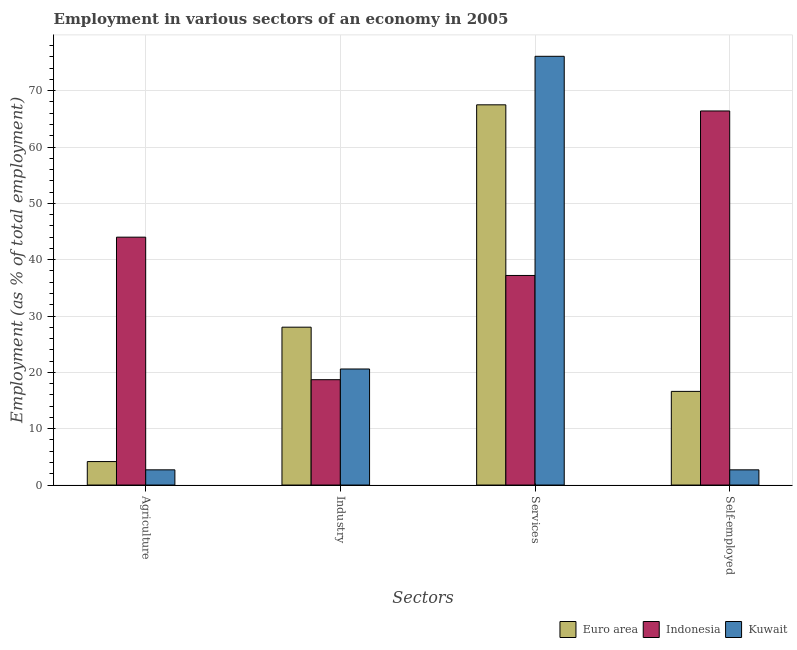How many different coloured bars are there?
Ensure brevity in your answer.  3. How many bars are there on the 2nd tick from the left?
Your answer should be very brief. 3. How many bars are there on the 3rd tick from the right?
Give a very brief answer. 3. What is the label of the 1st group of bars from the left?
Keep it short and to the point. Agriculture. What is the percentage of workers in services in Kuwait?
Provide a succinct answer. 76.1. Across all countries, what is the maximum percentage of workers in services?
Your response must be concise. 76.1. Across all countries, what is the minimum percentage of workers in services?
Give a very brief answer. 37.2. In which country was the percentage of workers in services maximum?
Offer a terse response. Kuwait. In which country was the percentage of workers in services minimum?
Give a very brief answer. Indonesia. What is the total percentage of workers in services in the graph?
Offer a very short reply. 180.79. What is the difference between the percentage of self employed workers in Kuwait and that in Indonesia?
Make the answer very short. -63.7. What is the difference between the percentage of self employed workers in Euro area and the percentage of workers in industry in Kuwait?
Provide a succinct answer. -3.98. What is the average percentage of workers in industry per country?
Your answer should be very brief. 22.44. What is the difference between the percentage of workers in agriculture and percentage of workers in services in Euro area?
Provide a short and direct response. -63.32. What is the ratio of the percentage of workers in services in Kuwait to that in Euro area?
Provide a short and direct response. 1.13. Is the difference between the percentage of workers in industry in Indonesia and Kuwait greater than the difference between the percentage of workers in services in Indonesia and Kuwait?
Give a very brief answer. Yes. What is the difference between the highest and the second highest percentage of workers in agriculture?
Make the answer very short. 39.83. What is the difference between the highest and the lowest percentage of workers in industry?
Provide a short and direct response. 9.32. In how many countries, is the percentage of workers in agriculture greater than the average percentage of workers in agriculture taken over all countries?
Your answer should be compact. 1. Is the sum of the percentage of workers in agriculture in Kuwait and Indonesia greater than the maximum percentage of workers in industry across all countries?
Provide a short and direct response. Yes. Is it the case that in every country, the sum of the percentage of workers in industry and percentage of workers in agriculture is greater than the sum of percentage of workers in services and percentage of self employed workers?
Your answer should be very brief. No. What does the 1st bar from the left in Industry represents?
Ensure brevity in your answer.  Euro area. What does the 1st bar from the right in Services represents?
Your answer should be compact. Kuwait. Is it the case that in every country, the sum of the percentage of workers in agriculture and percentage of workers in industry is greater than the percentage of workers in services?
Offer a terse response. No. How many bars are there?
Keep it short and to the point. 12. Are the values on the major ticks of Y-axis written in scientific E-notation?
Make the answer very short. No. Does the graph contain any zero values?
Offer a very short reply. No. How are the legend labels stacked?
Your answer should be very brief. Horizontal. What is the title of the graph?
Give a very brief answer. Employment in various sectors of an economy in 2005. What is the label or title of the X-axis?
Your response must be concise. Sectors. What is the label or title of the Y-axis?
Your response must be concise. Employment (as % of total employment). What is the Employment (as % of total employment) in Euro area in Agriculture?
Provide a succinct answer. 4.17. What is the Employment (as % of total employment) in Indonesia in Agriculture?
Your answer should be very brief. 44. What is the Employment (as % of total employment) in Kuwait in Agriculture?
Your response must be concise. 2.7. What is the Employment (as % of total employment) in Euro area in Industry?
Provide a short and direct response. 28.02. What is the Employment (as % of total employment) of Indonesia in Industry?
Keep it short and to the point. 18.7. What is the Employment (as % of total employment) of Kuwait in Industry?
Ensure brevity in your answer.  20.6. What is the Employment (as % of total employment) of Euro area in Services?
Ensure brevity in your answer.  67.49. What is the Employment (as % of total employment) of Indonesia in Services?
Provide a short and direct response. 37.2. What is the Employment (as % of total employment) of Kuwait in Services?
Keep it short and to the point. 76.1. What is the Employment (as % of total employment) of Euro area in Self-employed?
Ensure brevity in your answer.  16.62. What is the Employment (as % of total employment) in Indonesia in Self-employed?
Keep it short and to the point. 66.4. What is the Employment (as % of total employment) of Kuwait in Self-employed?
Offer a very short reply. 2.7. Across all Sectors, what is the maximum Employment (as % of total employment) of Euro area?
Provide a succinct answer. 67.49. Across all Sectors, what is the maximum Employment (as % of total employment) in Indonesia?
Offer a terse response. 66.4. Across all Sectors, what is the maximum Employment (as % of total employment) in Kuwait?
Ensure brevity in your answer.  76.1. Across all Sectors, what is the minimum Employment (as % of total employment) of Euro area?
Provide a succinct answer. 4.17. Across all Sectors, what is the minimum Employment (as % of total employment) of Indonesia?
Offer a terse response. 18.7. Across all Sectors, what is the minimum Employment (as % of total employment) of Kuwait?
Your answer should be compact. 2.7. What is the total Employment (as % of total employment) of Euro area in the graph?
Keep it short and to the point. 116.3. What is the total Employment (as % of total employment) in Indonesia in the graph?
Give a very brief answer. 166.3. What is the total Employment (as % of total employment) of Kuwait in the graph?
Provide a succinct answer. 102.1. What is the difference between the Employment (as % of total employment) of Euro area in Agriculture and that in Industry?
Provide a succinct answer. -23.86. What is the difference between the Employment (as % of total employment) in Indonesia in Agriculture and that in Industry?
Offer a very short reply. 25.3. What is the difference between the Employment (as % of total employment) in Kuwait in Agriculture and that in Industry?
Ensure brevity in your answer.  -17.9. What is the difference between the Employment (as % of total employment) in Euro area in Agriculture and that in Services?
Your answer should be compact. -63.32. What is the difference between the Employment (as % of total employment) in Indonesia in Agriculture and that in Services?
Ensure brevity in your answer.  6.8. What is the difference between the Employment (as % of total employment) in Kuwait in Agriculture and that in Services?
Your answer should be very brief. -73.4. What is the difference between the Employment (as % of total employment) in Euro area in Agriculture and that in Self-employed?
Give a very brief answer. -12.46. What is the difference between the Employment (as % of total employment) in Indonesia in Agriculture and that in Self-employed?
Ensure brevity in your answer.  -22.4. What is the difference between the Employment (as % of total employment) in Euro area in Industry and that in Services?
Your response must be concise. -39.47. What is the difference between the Employment (as % of total employment) in Indonesia in Industry and that in Services?
Provide a succinct answer. -18.5. What is the difference between the Employment (as % of total employment) of Kuwait in Industry and that in Services?
Your answer should be compact. -55.5. What is the difference between the Employment (as % of total employment) of Euro area in Industry and that in Self-employed?
Give a very brief answer. 11.4. What is the difference between the Employment (as % of total employment) of Indonesia in Industry and that in Self-employed?
Provide a short and direct response. -47.7. What is the difference between the Employment (as % of total employment) of Kuwait in Industry and that in Self-employed?
Offer a terse response. 17.9. What is the difference between the Employment (as % of total employment) in Euro area in Services and that in Self-employed?
Keep it short and to the point. 50.86. What is the difference between the Employment (as % of total employment) of Indonesia in Services and that in Self-employed?
Give a very brief answer. -29.2. What is the difference between the Employment (as % of total employment) in Kuwait in Services and that in Self-employed?
Offer a terse response. 73.4. What is the difference between the Employment (as % of total employment) in Euro area in Agriculture and the Employment (as % of total employment) in Indonesia in Industry?
Your answer should be compact. -14.53. What is the difference between the Employment (as % of total employment) of Euro area in Agriculture and the Employment (as % of total employment) of Kuwait in Industry?
Provide a succinct answer. -16.43. What is the difference between the Employment (as % of total employment) of Indonesia in Agriculture and the Employment (as % of total employment) of Kuwait in Industry?
Your response must be concise. 23.4. What is the difference between the Employment (as % of total employment) of Euro area in Agriculture and the Employment (as % of total employment) of Indonesia in Services?
Make the answer very short. -33.03. What is the difference between the Employment (as % of total employment) of Euro area in Agriculture and the Employment (as % of total employment) of Kuwait in Services?
Ensure brevity in your answer.  -71.93. What is the difference between the Employment (as % of total employment) in Indonesia in Agriculture and the Employment (as % of total employment) in Kuwait in Services?
Ensure brevity in your answer.  -32.1. What is the difference between the Employment (as % of total employment) of Euro area in Agriculture and the Employment (as % of total employment) of Indonesia in Self-employed?
Keep it short and to the point. -62.23. What is the difference between the Employment (as % of total employment) in Euro area in Agriculture and the Employment (as % of total employment) in Kuwait in Self-employed?
Provide a short and direct response. 1.47. What is the difference between the Employment (as % of total employment) in Indonesia in Agriculture and the Employment (as % of total employment) in Kuwait in Self-employed?
Offer a very short reply. 41.3. What is the difference between the Employment (as % of total employment) of Euro area in Industry and the Employment (as % of total employment) of Indonesia in Services?
Offer a very short reply. -9.18. What is the difference between the Employment (as % of total employment) of Euro area in Industry and the Employment (as % of total employment) of Kuwait in Services?
Keep it short and to the point. -48.08. What is the difference between the Employment (as % of total employment) in Indonesia in Industry and the Employment (as % of total employment) in Kuwait in Services?
Make the answer very short. -57.4. What is the difference between the Employment (as % of total employment) of Euro area in Industry and the Employment (as % of total employment) of Indonesia in Self-employed?
Provide a short and direct response. -38.38. What is the difference between the Employment (as % of total employment) in Euro area in Industry and the Employment (as % of total employment) in Kuwait in Self-employed?
Keep it short and to the point. 25.32. What is the difference between the Employment (as % of total employment) in Indonesia in Industry and the Employment (as % of total employment) in Kuwait in Self-employed?
Provide a succinct answer. 16. What is the difference between the Employment (as % of total employment) in Euro area in Services and the Employment (as % of total employment) in Indonesia in Self-employed?
Your answer should be very brief. 1.09. What is the difference between the Employment (as % of total employment) of Euro area in Services and the Employment (as % of total employment) of Kuwait in Self-employed?
Provide a succinct answer. 64.79. What is the difference between the Employment (as % of total employment) of Indonesia in Services and the Employment (as % of total employment) of Kuwait in Self-employed?
Offer a terse response. 34.5. What is the average Employment (as % of total employment) of Euro area per Sectors?
Your answer should be very brief. 29.07. What is the average Employment (as % of total employment) of Indonesia per Sectors?
Offer a terse response. 41.58. What is the average Employment (as % of total employment) in Kuwait per Sectors?
Offer a terse response. 25.52. What is the difference between the Employment (as % of total employment) in Euro area and Employment (as % of total employment) in Indonesia in Agriculture?
Ensure brevity in your answer.  -39.83. What is the difference between the Employment (as % of total employment) in Euro area and Employment (as % of total employment) in Kuwait in Agriculture?
Your response must be concise. 1.47. What is the difference between the Employment (as % of total employment) of Indonesia and Employment (as % of total employment) of Kuwait in Agriculture?
Offer a terse response. 41.3. What is the difference between the Employment (as % of total employment) of Euro area and Employment (as % of total employment) of Indonesia in Industry?
Offer a very short reply. 9.32. What is the difference between the Employment (as % of total employment) of Euro area and Employment (as % of total employment) of Kuwait in Industry?
Your answer should be very brief. 7.42. What is the difference between the Employment (as % of total employment) in Euro area and Employment (as % of total employment) in Indonesia in Services?
Offer a terse response. 30.29. What is the difference between the Employment (as % of total employment) of Euro area and Employment (as % of total employment) of Kuwait in Services?
Your answer should be compact. -8.61. What is the difference between the Employment (as % of total employment) in Indonesia and Employment (as % of total employment) in Kuwait in Services?
Provide a succinct answer. -38.9. What is the difference between the Employment (as % of total employment) of Euro area and Employment (as % of total employment) of Indonesia in Self-employed?
Provide a succinct answer. -49.78. What is the difference between the Employment (as % of total employment) of Euro area and Employment (as % of total employment) of Kuwait in Self-employed?
Make the answer very short. 13.92. What is the difference between the Employment (as % of total employment) of Indonesia and Employment (as % of total employment) of Kuwait in Self-employed?
Your response must be concise. 63.7. What is the ratio of the Employment (as % of total employment) of Euro area in Agriculture to that in Industry?
Offer a very short reply. 0.15. What is the ratio of the Employment (as % of total employment) in Indonesia in Agriculture to that in Industry?
Give a very brief answer. 2.35. What is the ratio of the Employment (as % of total employment) of Kuwait in Agriculture to that in Industry?
Make the answer very short. 0.13. What is the ratio of the Employment (as % of total employment) in Euro area in Agriculture to that in Services?
Give a very brief answer. 0.06. What is the ratio of the Employment (as % of total employment) of Indonesia in Agriculture to that in Services?
Give a very brief answer. 1.18. What is the ratio of the Employment (as % of total employment) of Kuwait in Agriculture to that in Services?
Your answer should be compact. 0.04. What is the ratio of the Employment (as % of total employment) in Euro area in Agriculture to that in Self-employed?
Provide a short and direct response. 0.25. What is the ratio of the Employment (as % of total employment) in Indonesia in Agriculture to that in Self-employed?
Your response must be concise. 0.66. What is the ratio of the Employment (as % of total employment) in Kuwait in Agriculture to that in Self-employed?
Your response must be concise. 1. What is the ratio of the Employment (as % of total employment) of Euro area in Industry to that in Services?
Offer a terse response. 0.42. What is the ratio of the Employment (as % of total employment) in Indonesia in Industry to that in Services?
Your response must be concise. 0.5. What is the ratio of the Employment (as % of total employment) in Kuwait in Industry to that in Services?
Give a very brief answer. 0.27. What is the ratio of the Employment (as % of total employment) in Euro area in Industry to that in Self-employed?
Provide a succinct answer. 1.69. What is the ratio of the Employment (as % of total employment) of Indonesia in Industry to that in Self-employed?
Your answer should be compact. 0.28. What is the ratio of the Employment (as % of total employment) of Kuwait in Industry to that in Self-employed?
Provide a short and direct response. 7.63. What is the ratio of the Employment (as % of total employment) of Euro area in Services to that in Self-employed?
Your answer should be compact. 4.06. What is the ratio of the Employment (as % of total employment) of Indonesia in Services to that in Self-employed?
Make the answer very short. 0.56. What is the ratio of the Employment (as % of total employment) of Kuwait in Services to that in Self-employed?
Make the answer very short. 28.19. What is the difference between the highest and the second highest Employment (as % of total employment) in Euro area?
Keep it short and to the point. 39.47. What is the difference between the highest and the second highest Employment (as % of total employment) in Indonesia?
Your answer should be very brief. 22.4. What is the difference between the highest and the second highest Employment (as % of total employment) in Kuwait?
Your response must be concise. 55.5. What is the difference between the highest and the lowest Employment (as % of total employment) in Euro area?
Your answer should be compact. 63.32. What is the difference between the highest and the lowest Employment (as % of total employment) of Indonesia?
Your response must be concise. 47.7. What is the difference between the highest and the lowest Employment (as % of total employment) of Kuwait?
Offer a terse response. 73.4. 